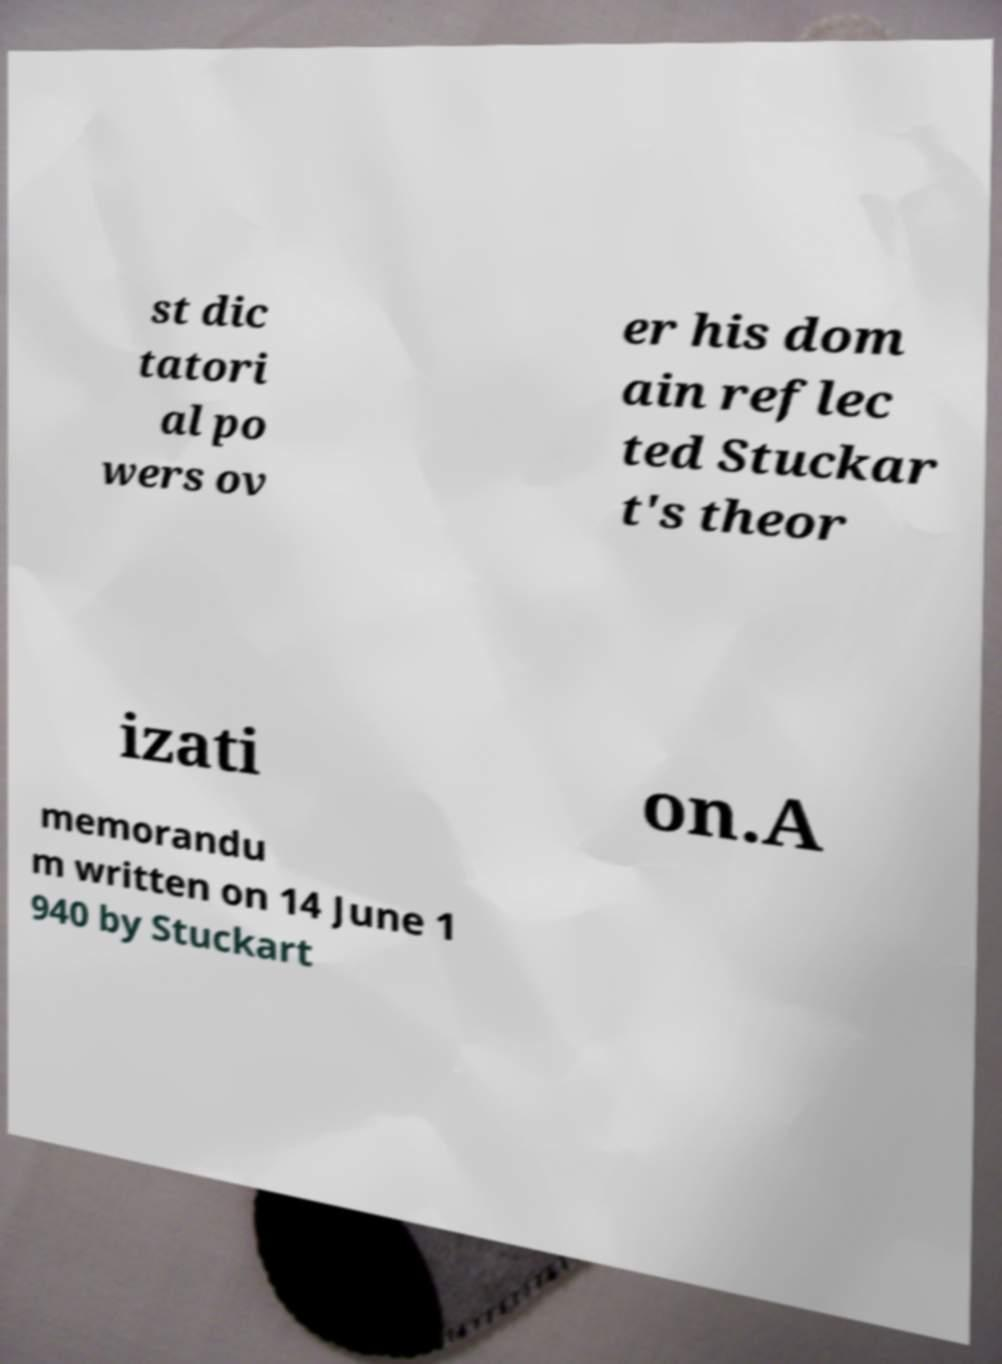Could you assist in decoding the text presented in this image and type it out clearly? st dic tatori al po wers ov er his dom ain reflec ted Stuckar t's theor izati on.A memorandu m written on 14 June 1 940 by Stuckart 